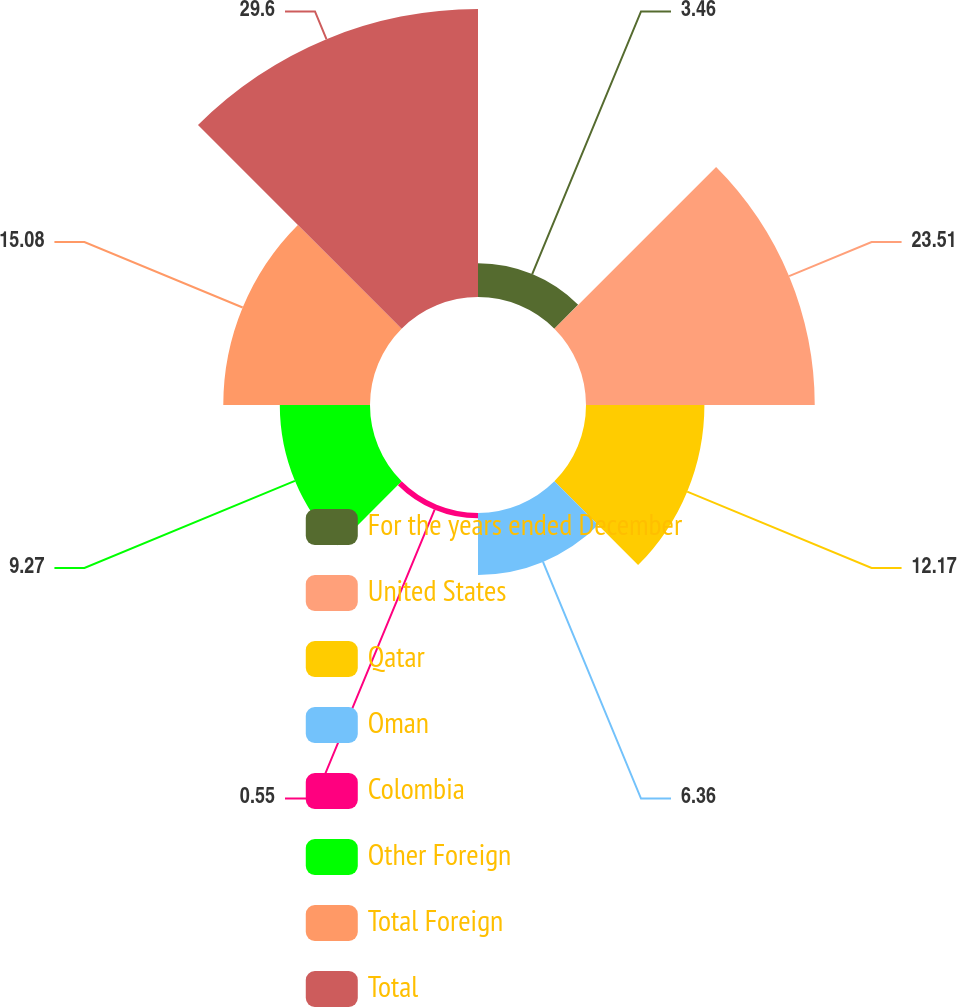<chart> <loc_0><loc_0><loc_500><loc_500><pie_chart><fcel>For the years ended December<fcel>United States<fcel>Qatar<fcel>Oman<fcel>Colombia<fcel>Other Foreign<fcel>Total Foreign<fcel>Total<nl><fcel>3.46%<fcel>23.51%<fcel>12.17%<fcel>6.36%<fcel>0.55%<fcel>9.27%<fcel>15.08%<fcel>29.6%<nl></chart> 